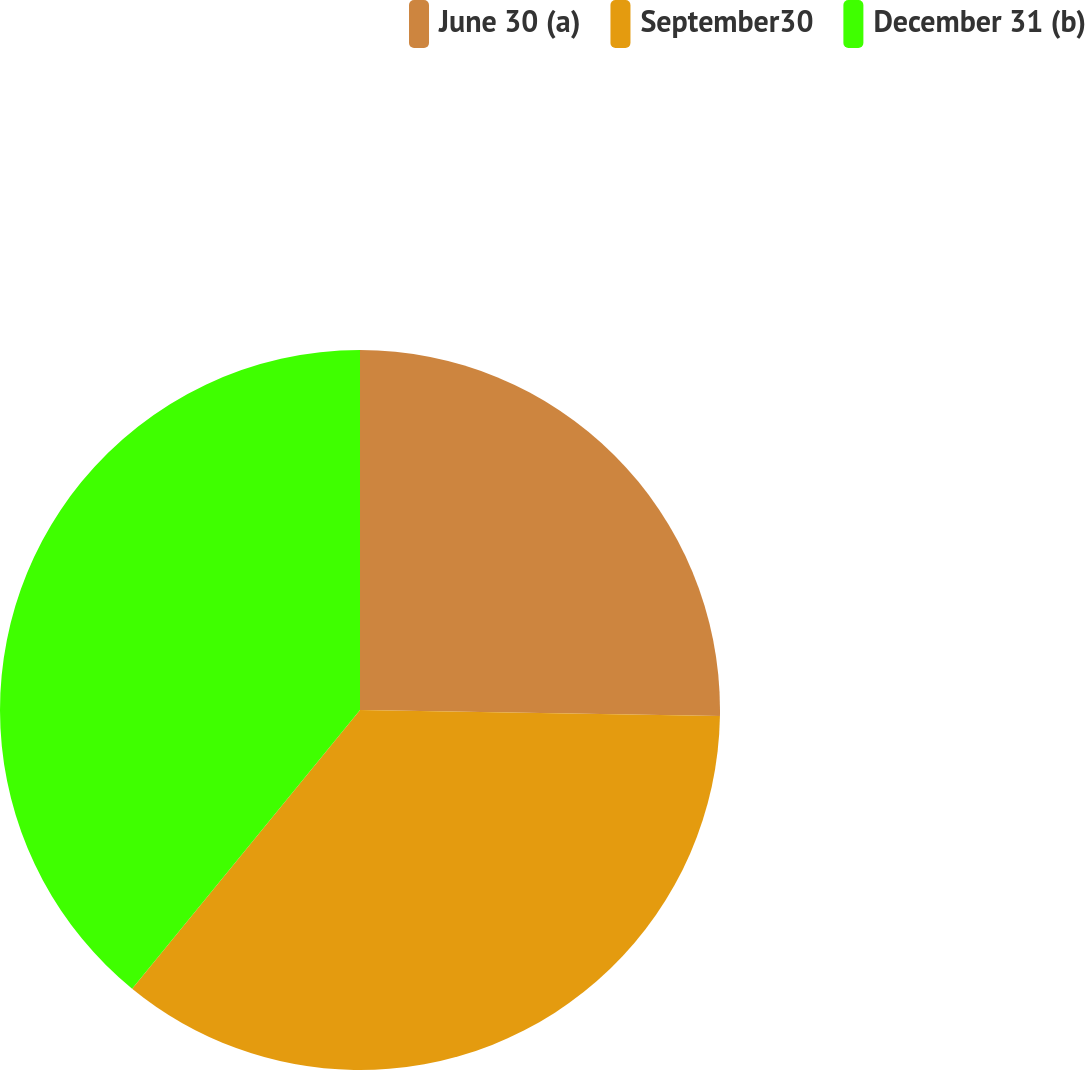Convert chart to OTSL. <chart><loc_0><loc_0><loc_500><loc_500><pie_chart><fcel>June 30 (a)<fcel>September30<fcel>December 31 (b)<nl><fcel>25.27%<fcel>35.64%<fcel>39.09%<nl></chart> 